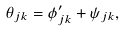<formula> <loc_0><loc_0><loc_500><loc_500>\theta _ { j k } = \phi ^ { \prime } _ { j k } + \psi _ { j k } ,</formula> 